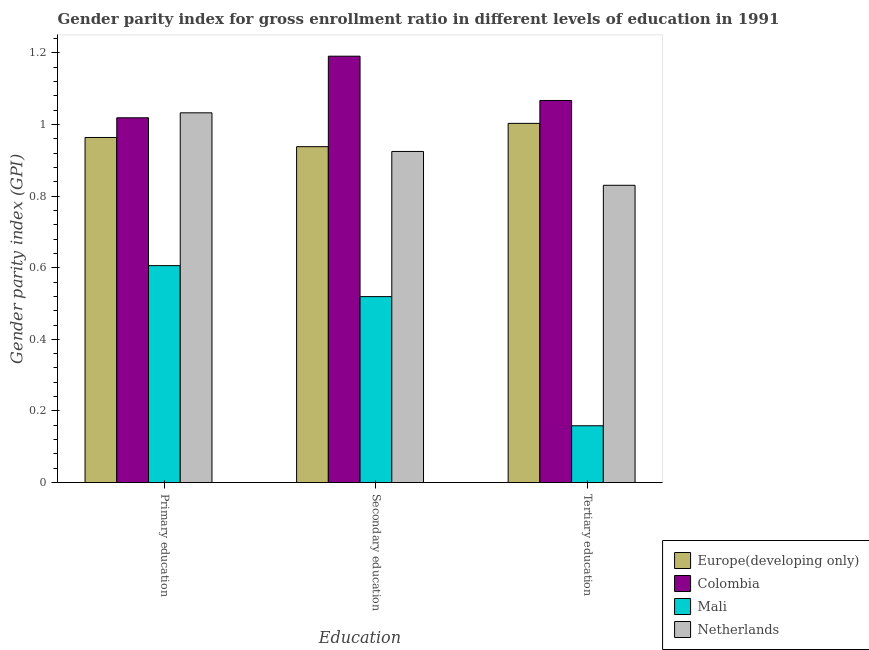How many different coloured bars are there?
Provide a succinct answer. 4. How many groups of bars are there?
Offer a terse response. 3. How many bars are there on the 2nd tick from the left?
Make the answer very short. 4. How many bars are there on the 2nd tick from the right?
Make the answer very short. 4. What is the label of the 2nd group of bars from the left?
Your answer should be compact. Secondary education. What is the gender parity index in secondary education in Colombia?
Give a very brief answer. 1.19. Across all countries, what is the maximum gender parity index in tertiary education?
Your answer should be compact. 1.07. Across all countries, what is the minimum gender parity index in tertiary education?
Keep it short and to the point. 0.16. In which country was the gender parity index in primary education minimum?
Your answer should be compact. Mali. What is the total gender parity index in secondary education in the graph?
Offer a very short reply. 3.57. What is the difference between the gender parity index in tertiary education in Netherlands and that in Colombia?
Your answer should be very brief. -0.24. What is the difference between the gender parity index in tertiary education in Europe(developing only) and the gender parity index in secondary education in Mali?
Your answer should be compact. 0.48. What is the average gender parity index in secondary education per country?
Make the answer very short. 0.89. What is the difference between the gender parity index in tertiary education and gender parity index in primary education in Netherlands?
Your answer should be compact. -0.2. In how many countries, is the gender parity index in secondary education greater than 0.7200000000000001 ?
Keep it short and to the point. 3. What is the ratio of the gender parity index in tertiary education in Mali to that in Colombia?
Ensure brevity in your answer.  0.15. Is the gender parity index in tertiary education in Mali less than that in Netherlands?
Your answer should be very brief. Yes. Is the difference between the gender parity index in primary education in Colombia and Netherlands greater than the difference between the gender parity index in tertiary education in Colombia and Netherlands?
Your answer should be compact. No. What is the difference between the highest and the second highest gender parity index in secondary education?
Give a very brief answer. 0.25. What is the difference between the highest and the lowest gender parity index in secondary education?
Provide a succinct answer. 0.67. In how many countries, is the gender parity index in secondary education greater than the average gender parity index in secondary education taken over all countries?
Provide a succinct answer. 3. Is the sum of the gender parity index in secondary education in Colombia and Mali greater than the maximum gender parity index in primary education across all countries?
Ensure brevity in your answer.  Yes. What does the 4th bar from the right in Tertiary education represents?
Your answer should be compact. Europe(developing only). How many bars are there?
Make the answer very short. 12. Are all the bars in the graph horizontal?
Your answer should be very brief. No. How many countries are there in the graph?
Your response must be concise. 4. What is the difference between two consecutive major ticks on the Y-axis?
Make the answer very short. 0.2. Are the values on the major ticks of Y-axis written in scientific E-notation?
Ensure brevity in your answer.  No. What is the title of the graph?
Ensure brevity in your answer.  Gender parity index for gross enrollment ratio in different levels of education in 1991. Does "Netherlands" appear as one of the legend labels in the graph?
Your response must be concise. Yes. What is the label or title of the X-axis?
Offer a terse response. Education. What is the label or title of the Y-axis?
Ensure brevity in your answer.  Gender parity index (GPI). What is the Gender parity index (GPI) of Europe(developing only) in Primary education?
Your answer should be compact. 0.96. What is the Gender parity index (GPI) of Colombia in Primary education?
Your response must be concise. 1.02. What is the Gender parity index (GPI) in Mali in Primary education?
Keep it short and to the point. 0.61. What is the Gender parity index (GPI) in Netherlands in Primary education?
Provide a succinct answer. 1.03. What is the Gender parity index (GPI) of Europe(developing only) in Secondary education?
Ensure brevity in your answer.  0.94. What is the Gender parity index (GPI) in Colombia in Secondary education?
Your response must be concise. 1.19. What is the Gender parity index (GPI) in Mali in Secondary education?
Your response must be concise. 0.52. What is the Gender parity index (GPI) in Netherlands in Secondary education?
Provide a succinct answer. 0.92. What is the Gender parity index (GPI) in Europe(developing only) in Tertiary education?
Ensure brevity in your answer.  1. What is the Gender parity index (GPI) of Colombia in Tertiary education?
Provide a short and direct response. 1.07. What is the Gender parity index (GPI) of Mali in Tertiary education?
Your response must be concise. 0.16. What is the Gender parity index (GPI) in Netherlands in Tertiary education?
Offer a terse response. 0.83. Across all Education, what is the maximum Gender parity index (GPI) of Europe(developing only)?
Provide a succinct answer. 1. Across all Education, what is the maximum Gender parity index (GPI) in Colombia?
Ensure brevity in your answer.  1.19. Across all Education, what is the maximum Gender parity index (GPI) of Mali?
Offer a very short reply. 0.61. Across all Education, what is the maximum Gender parity index (GPI) of Netherlands?
Make the answer very short. 1.03. Across all Education, what is the minimum Gender parity index (GPI) of Europe(developing only)?
Provide a short and direct response. 0.94. Across all Education, what is the minimum Gender parity index (GPI) of Colombia?
Ensure brevity in your answer.  1.02. Across all Education, what is the minimum Gender parity index (GPI) in Mali?
Offer a very short reply. 0.16. Across all Education, what is the minimum Gender parity index (GPI) of Netherlands?
Provide a succinct answer. 0.83. What is the total Gender parity index (GPI) of Europe(developing only) in the graph?
Offer a very short reply. 2.9. What is the total Gender parity index (GPI) of Colombia in the graph?
Provide a short and direct response. 3.28. What is the total Gender parity index (GPI) in Mali in the graph?
Offer a terse response. 1.28. What is the total Gender parity index (GPI) of Netherlands in the graph?
Give a very brief answer. 2.79. What is the difference between the Gender parity index (GPI) of Europe(developing only) in Primary education and that in Secondary education?
Provide a succinct answer. 0.03. What is the difference between the Gender parity index (GPI) of Colombia in Primary education and that in Secondary education?
Keep it short and to the point. -0.17. What is the difference between the Gender parity index (GPI) of Mali in Primary education and that in Secondary education?
Make the answer very short. 0.09. What is the difference between the Gender parity index (GPI) of Netherlands in Primary education and that in Secondary education?
Offer a terse response. 0.11. What is the difference between the Gender parity index (GPI) in Europe(developing only) in Primary education and that in Tertiary education?
Your answer should be very brief. -0.04. What is the difference between the Gender parity index (GPI) of Colombia in Primary education and that in Tertiary education?
Your answer should be very brief. -0.05. What is the difference between the Gender parity index (GPI) of Mali in Primary education and that in Tertiary education?
Offer a terse response. 0.45. What is the difference between the Gender parity index (GPI) of Netherlands in Primary education and that in Tertiary education?
Provide a short and direct response. 0.2. What is the difference between the Gender parity index (GPI) in Europe(developing only) in Secondary education and that in Tertiary education?
Your answer should be very brief. -0.07. What is the difference between the Gender parity index (GPI) in Colombia in Secondary education and that in Tertiary education?
Provide a succinct answer. 0.12. What is the difference between the Gender parity index (GPI) of Mali in Secondary education and that in Tertiary education?
Give a very brief answer. 0.36. What is the difference between the Gender parity index (GPI) in Netherlands in Secondary education and that in Tertiary education?
Ensure brevity in your answer.  0.09. What is the difference between the Gender parity index (GPI) in Europe(developing only) in Primary education and the Gender parity index (GPI) in Colombia in Secondary education?
Your answer should be very brief. -0.23. What is the difference between the Gender parity index (GPI) of Europe(developing only) in Primary education and the Gender parity index (GPI) of Mali in Secondary education?
Your response must be concise. 0.44. What is the difference between the Gender parity index (GPI) of Europe(developing only) in Primary education and the Gender parity index (GPI) of Netherlands in Secondary education?
Ensure brevity in your answer.  0.04. What is the difference between the Gender parity index (GPI) in Colombia in Primary education and the Gender parity index (GPI) in Mali in Secondary education?
Provide a succinct answer. 0.5. What is the difference between the Gender parity index (GPI) of Colombia in Primary education and the Gender parity index (GPI) of Netherlands in Secondary education?
Your response must be concise. 0.09. What is the difference between the Gender parity index (GPI) in Mali in Primary education and the Gender parity index (GPI) in Netherlands in Secondary education?
Make the answer very short. -0.32. What is the difference between the Gender parity index (GPI) of Europe(developing only) in Primary education and the Gender parity index (GPI) of Colombia in Tertiary education?
Offer a very short reply. -0.1. What is the difference between the Gender parity index (GPI) in Europe(developing only) in Primary education and the Gender parity index (GPI) in Mali in Tertiary education?
Provide a succinct answer. 0.8. What is the difference between the Gender parity index (GPI) of Europe(developing only) in Primary education and the Gender parity index (GPI) of Netherlands in Tertiary education?
Give a very brief answer. 0.13. What is the difference between the Gender parity index (GPI) in Colombia in Primary education and the Gender parity index (GPI) in Mali in Tertiary education?
Offer a very short reply. 0.86. What is the difference between the Gender parity index (GPI) in Colombia in Primary education and the Gender parity index (GPI) in Netherlands in Tertiary education?
Keep it short and to the point. 0.19. What is the difference between the Gender parity index (GPI) of Mali in Primary education and the Gender parity index (GPI) of Netherlands in Tertiary education?
Provide a succinct answer. -0.22. What is the difference between the Gender parity index (GPI) in Europe(developing only) in Secondary education and the Gender parity index (GPI) in Colombia in Tertiary education?
Offer a terse response. -0.13. What is the difference between the Gender parity index (GPI) in Europe(developing only) in Secondary education and the Gender parity index (GPI) in Mali in Tertiary education?
Your answer should be compact. 0.78. What is the difference between the Gender parity index (GPI) of Europe(developing only) in Secondary education and the Gender parity index (GPI) of Netherlands in Tertiary education?
Your answer should be very brief. 0.11. What is the difference between the Gender parity index (GPI) in Colombia in Secondary education and the Gender parity index (GPI) in Mali in Tertiary education?
Ensure brevity in your answer.  1.03. What is the difference between the Gender parity index (GPI) of Colombia in Secondary education and the Gender parity index (GPI) of Netherlands in Tertiary education?
Offer a very short reply. 0.36. What is the difference between the Gender parity index (GPI) in Mali in Secondary education and the Gender parity index (GPI) in Netherlands in Tertiary education?
Provide a short and direct response. -0.31. What is the average Gender parity index (GPI) of Europe(developing only) per Education?
Give a very brief answer. 0.97. What is the average Gender parity index (GPI) of Colombia per Education?
Offer a very short reply. 1.09. What is the average Gender parity index (GPI) of Mali per Education?
Give a very brief answer. 0.43. What is the average Gender parity index (GPI) of Netherlands per Education?
Give a very brief answer. 0.93. What is the difference between the Gender parity index (GPI) in Europe(developing only) and Gender parity index (GPI) in Colombia in Primary education?
Your answer should be very brief. -0.06. What is the difference between the Gender parity index (GPI) of Europe(developing only) and Gender parity index (GPI) of Mali in Primary education?
Offer a terse response. 0.36. What is the difference between the Gender parity index (GPI) in Europe(developing only) and Gender parity index (GPI) in Netherlands in Primary education?
Your answer should be compact. -0.07. What is the difference between the Gender parity index (GPI) in Colombia and Gender parity index (GPI) in Mali in Primary education?
Provide a succinct answer. 0.41. What is the difference between the Gender parity index (GPI) of Colombia and Gender parity index (GPI) of Netherlands in Primary education?
Give a very brief answer. -0.01. What is the difference between the Gender parity index (GPI) of Mali and Gender parity index (GPI) of Netherlands in Primary education?
Your response must be concise. -0.43. What is the difference between the Gender parity index (GPI) in Europe(developing only) and Gender parity index (GPI) in Colombia in Secondary education?
Offer a terse response. -0.25. What is the difference between the Gender parity index (GPI) in Europe(developing only) and Gender parity index (GPI) in Mali in Secondary education?
Ensure brevity in your answer.  0.42. What is the difference between the Gender parity index (GPI) in Europe(developing only) and Gender parity index (GPI) in Netherlands in Secondary education?
Keep it short and to the point. 0.01. What is the difference between the Gender parity index (GPI) in Colombia and Gender parity index (GPI) in Mali in Secondary education?
Your answer should be compact. 0.67. What is the difference between the Gender parity index (GPI) in Colombia and Gender parity index (GPI) in Netherlands in Secondary education?
Ensure brevity in your answer.  0.27. What is the difference between the Gender parity index (GPI) in Mali and Gender parity index (GPI) in Netherlands in Secondary education?
Offer a terse response. -0.41. What is the difference between the Gender parity index (GPI) in Europe(developing only) and Gender parity index (GPI) in Colombia in Tertiary education?
Provide a succinct answer. -0.06. What is the difference between the Gender parity index (GPI) of Europe(developing only) and Gender parity index (GPI) of Mali in Tertiary education?
Ensure brevity in your answer.  0.84. What is the difference between the Gender parity index (GPI) in Europe(developing only) and Gender parity index (GPI) in Netherlands in Tertiary education?
Offer a very short reply. 0.17. What is the difference between the Gender parity index (GPI) in Colombia and Gender parity index (GPI) in Mali in Tertiary education?
Offer a terse response. 0.91. What is the difference between the Gender parity index (GPI) of Colombia and Gender parity index (GPI) of Netherlands in Tertiary education?
Offer a very short reply. 0.24. What is the difference between the Gender parity index (GPI) in Mali and Gender parity index (GPI) in Netherlands in Tertiary education?
Make the answer very short. -0.67. What is the ratio of the Gender parity index (GPI) of Europe(developing only) in Primary education to that in Secondary education?
Provide a succinct answer. 1.03. What is the ratio of the Gender parity index (GPI) of Colombia in Primary education to that in Secondary education?
Keep it short and to the point. 0.86. What is the ratio of the Gender parity index (GPI) of Mali in Primary education to that in Secondary education?
Give a very brief answer. 1.17. What is the ratio of the Gender parity index (GPI) in Netherlands in Primary education to that in Secondary education?
Provide a succinct answer. 1.12. What is the ratio of the Gender parity index (GPI) in Europe(developing only) in Primary education to that in Tertiary education?
Give a very brief answer. 0.96. What is the ratio of the Gender parity index (GPI) in Colombia in Primary education to that in Tertiary education?
Provide a short and direct response. 0.95. What is the ratio of the Gender parity index (GPI) in Mali in Primary education to that in Tertiary education?
Your response must be concise. 3.82. What is the ratio of the Gender parity index (GPI) of Netherlands in Primary education to that in Tertiary education?
Your answer should be very brief. 1.24. What is the ratio of the Gender parity index (GPI) of Europe(developing only) in Secondary education to that in Tertiary education?
Your answer should be compact. 0.94. What is the ratio of the Gender parity index (GPI) of Colombia in Secondary education to that in Tertiary education?
Ensure brevity in your answer.  1.12. What is the ratio of the Gender parity index (GPI) of Mali in Secondary education to that in Tertiary education?
Make the answer very short. 3.27. What is the ratio of the Gender parity index (GPI) of Netherlands in Secondary education to that in Tertiary education?
Offer a very short reply. 1.11. What is the difference between the highest and the second highest Gender parity index (GPI) in Europe(developing only)?
Keep it short and to the point. 0.04. What is the difference between the highest and the second highest Gender parity index (GPI) in Colombia?
Offer a terse response. 0.12. What is the difference between the highest and the second highest Gender parity index (GPI) of Mali?
Keep it short and to the point. 0.09. What is the difference between the highest and the second highest Gender parity index (GPI) of Netherlands?
Ensure brevity in your answer.  0.11. What is the difference between the highest and the lowest Gender parity index (GPI) of Europe(developing only)?
Your answer should be compact. 0.07. What is the difference between the highest and the lowest Gender parity index (GPI) of Colombia?
Your answer should be very brief. 0.17. What is the difference between the highest and the lowest Gender parity index (GPI) of Mali?
Provide a short and direct response. 0.45. What is the difference between the highest and the lowest Gender parity index (GPI) in Netherlands?
Provide a succinct answer. 0.2. 